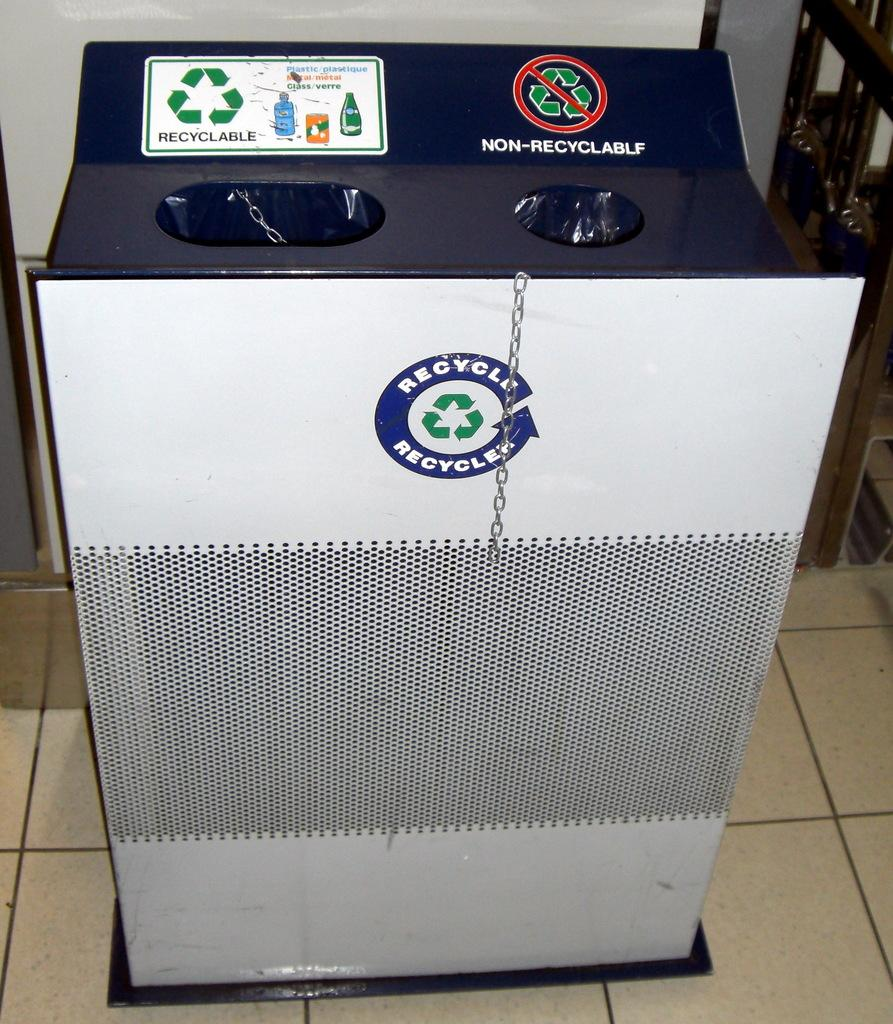<image>
Provide a brief description of the given image. The recycle bin has a log called Recycle on it 